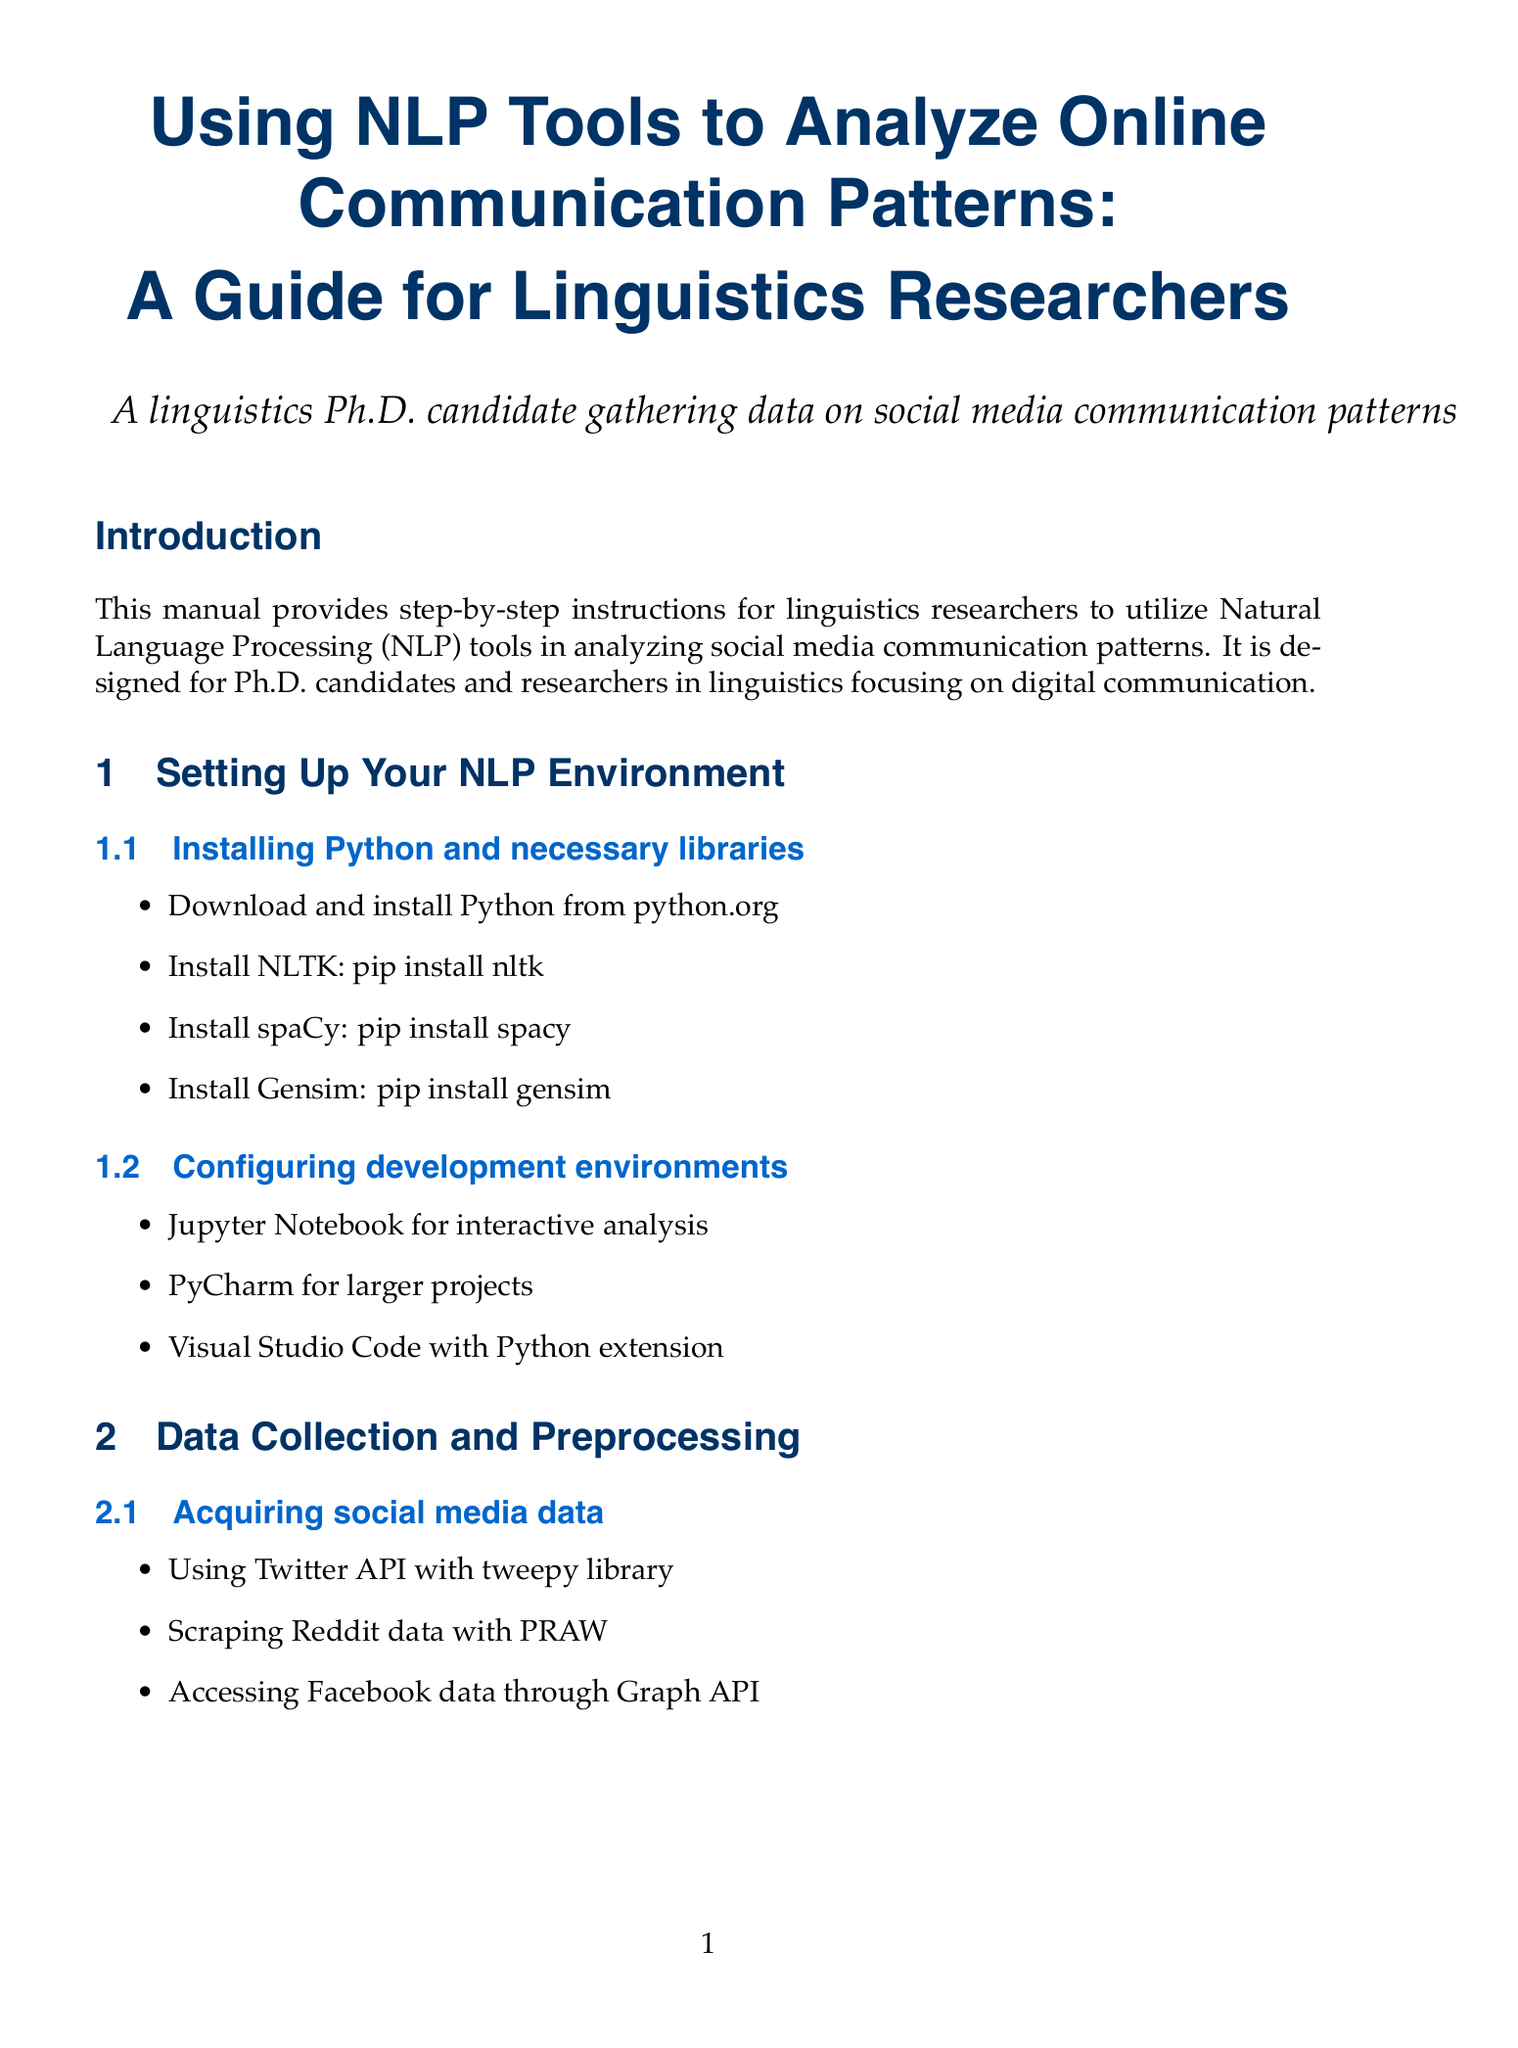What is the main purpose of the manual? The main purpose is stated in the introduction as providing step-by-step instructions for researchers to utilize NLP tools in analyzing social media communication patterns.
Answer: Analyzing social media communication patterns Who is the target audience for this manual? The introduction specifies that the target audience is Ph.D. candidates and researchers in linguistics focusing on digital communication.
Answer: Ph.D. candidates and researchers in linguistics What library is installed using the command "pip install nltk"? The steps under "Installing Python and necessary libraries" section specify that this command is for installing the NLTK library specifically.
Answer: NLTK Which technique is used for Named Entity Recognition? The "Named Entity Recognition" section mentions using spaCy's NER model as one of the techniques.
Answer: spaCy's NER model What is one approach to sentiment analysis mentioned in the document? The "Sentiment Analysis" section lists VADER sentiment analyzer in NLTK as one of the approaches for sentiment analysis.
Answer: VADER sentiment analyzer How many methods for acquiring social media data are listed? The "Acquiring social media data" section details three methods, thus the count is derived from that information.
Answer: Three What is a tool suggested for visualizing communication networks? In the "Network Analysis of Communication Patterns" section, it mentions Gephi as a tool for visualizing communication networks.
Answer: Gephi What statistical technique is used for descriptive statistics? The "Statistical Analysis" section indicates that pandas is used for descriptive statistics.
Answer: pandas 